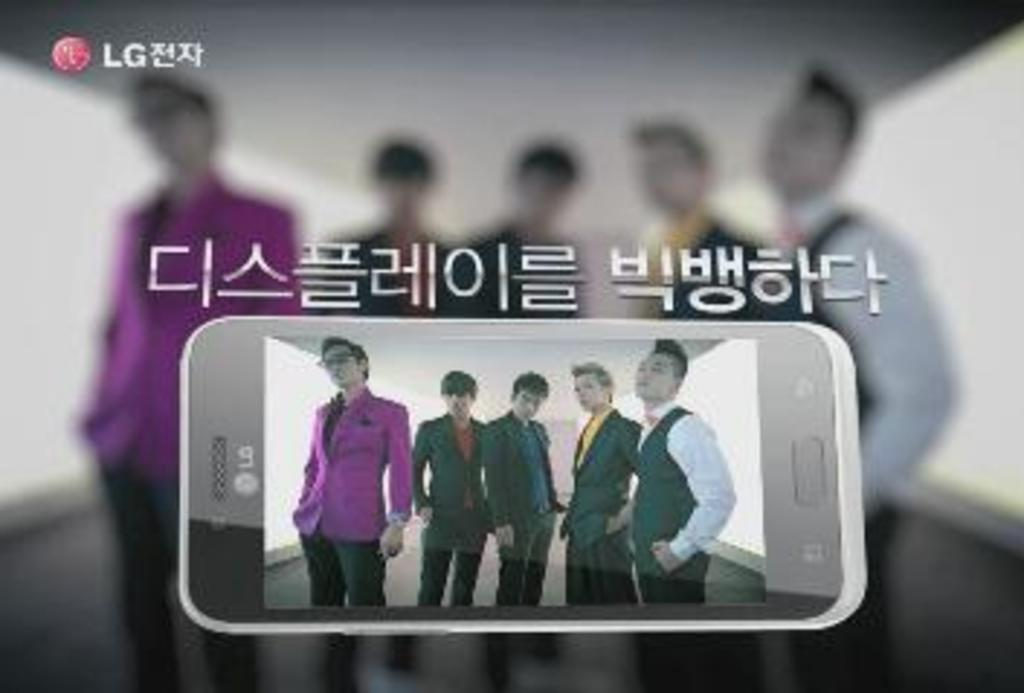How many people are visible in the image? There are four members visible in the image. Where are the members located? The members are on a mobile screen. What are the members wearing? All members are wearing coats. What else can be seen in the image besides the members? There is some text in the image. Can you describe the background of the image? The background is blurred. What type of chalk is being used to draw on the salt in the image? There is no chalk or salt present in the image. How many flowers are visible in the image? There are no flowers visible in the image. 